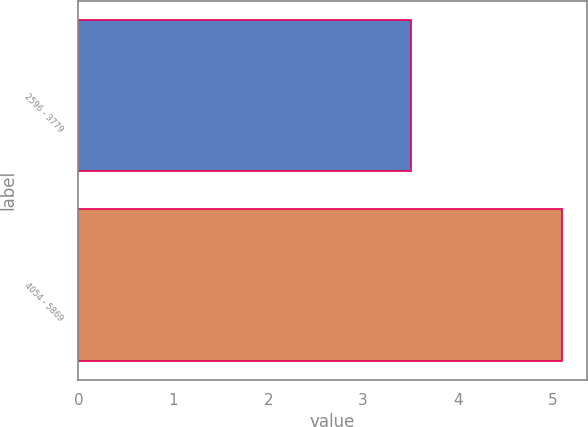<chart> <loc_0><loc_0><loc_500><loc_500><bar_chart><fcel>2596 - 3779<fcel>4054 - 5869<nl><fcel>3.5<fcel>5.1<nl></chart> 